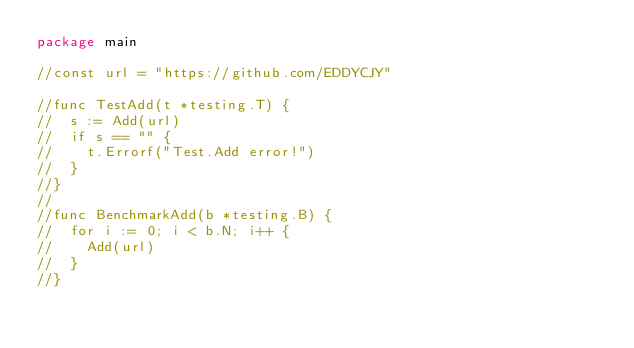<code> <loc_0><loc_0><loc_500><loc_500><_Go_>package main

//const url = "https://github.com/EDDYCJY"

//func TestAdd(t *testing.T) {
//	s := Add(url)
//	if s == "" {
//		t.Errorf("Test.Add error!")
//	}
//}
//
//func BenchmarkAdd(b *testing.B) {
//	for i := 0; i < b.N; i++ {
//		Add(url)
//	}
//}
</code> 